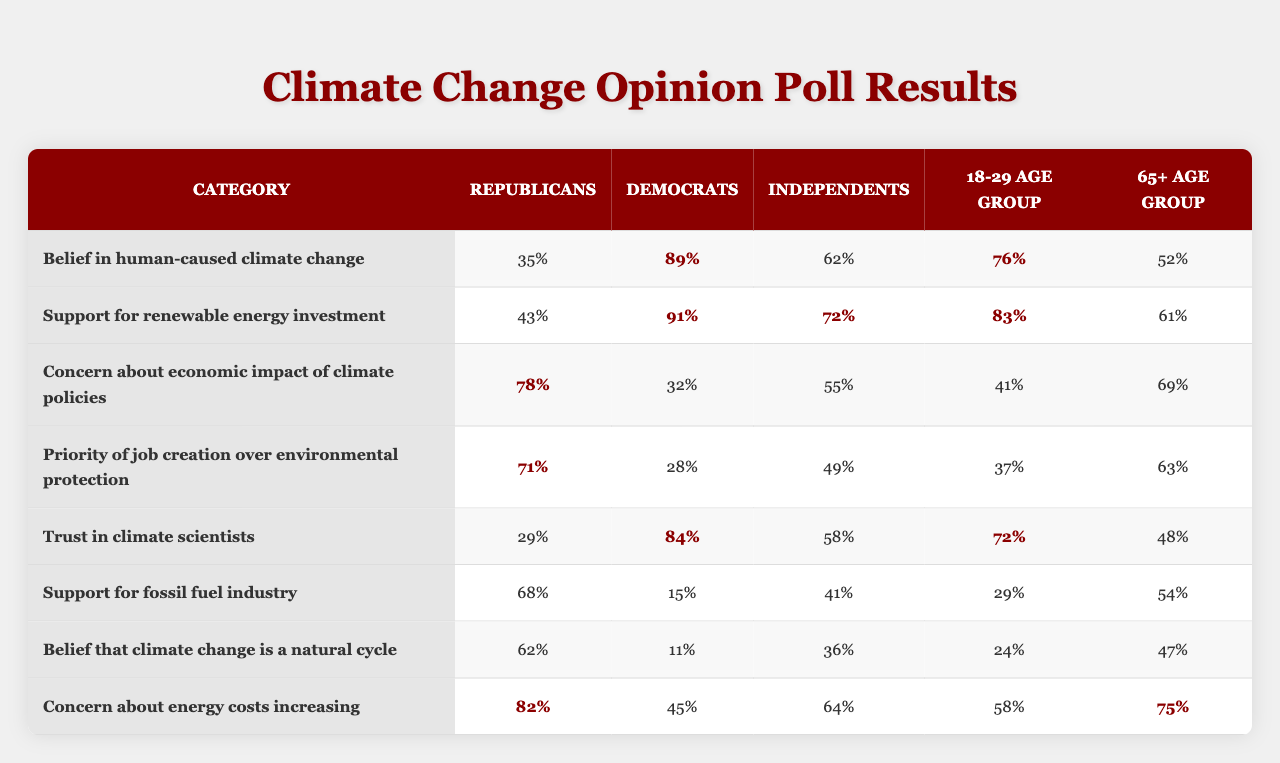What percentage of Republicans believe in human-caused climate change? From the table, the row for "Belief in human-caused climate change" shows that 35% of Republicans hold this belief.
Answer: 35% What is the percentage of Democrats who support renewable energy investment? The table indicates that 91% of Democrats support renewable energy investment as it is stated in the corresponding row under the "Democrats" column.
Answer: 91% Which age group shows the highest concern about energy costs increasing? In the row labeled "Concern about energy costs increasing," the highest percentage is 82%, from the "Republicans" column, indicating they show the most concern among the age groups.
Answer: 82% What is the difference in belief about climate change being a natural cycle between Republicans and Independents? The belief that climate change is a natural cycle shows 62% for Republicans and 36% for Independents. The difference is calculated as 62% - 36% = 26%.
Answer: 26% What is the average percentage of concern about economic impacts of climate policies among all groups? To find the average, sum the values: (43 + 28 + 32 + 62 + 84 + 15 + 11 + 45) = 320. There are 8 groups, so the average is 320/8 = 40%.
Answer: 40% Do more than 70% of Independents support fossil fuel industry? According to the "Support for fossil fuel industry" row, 41% of Independents support it, which is less than 70%.
Answer: No Which group prioritizes job creation over environmental protection the most? From the row "Priority of job creation over environmental protection," Republicans have the highest percentage at 71%.
Answer: Republicans What is the average percentage of belief that climate change is a natural cycle for the 65+ age group when compared to Republicans? The table indicates that Republicans show 62% belief in natural cycles, while 47% is shown for the 65+ age group. The average for both would be (62 + 47) / 2 = 54.5%.
Answer: 54.5% What group has the least trust in climate scientists? The row "Trust in climate scientists" shows that only 15% of Republicans trust climate scientists, which is the lowest among the groups.
Answer: Republicans Is there a majority support for renewable energy investment among the 18-29 age group? The percentage of support for renewable energy investment among the 18-29 age group is seen to be 76%, which is indeed a majority (over 50%).
Answer: Yes 